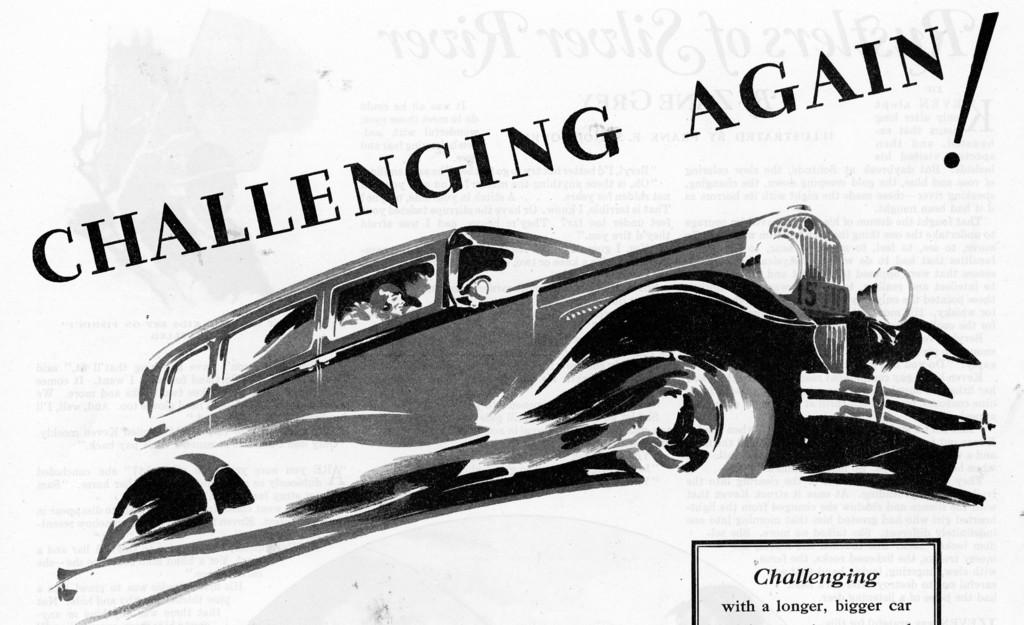What is the main subject of the picture? The main subject of the picture is an art of a car. Is there any text present in the image? Yes, there is some text in the middle of the picture. What color is the background of the image? The background of the image is white. How many frogs can be seen sitting on the bed in the image? There are no frogs or beds present in the image; it features an art of a car and some text on a white background. 